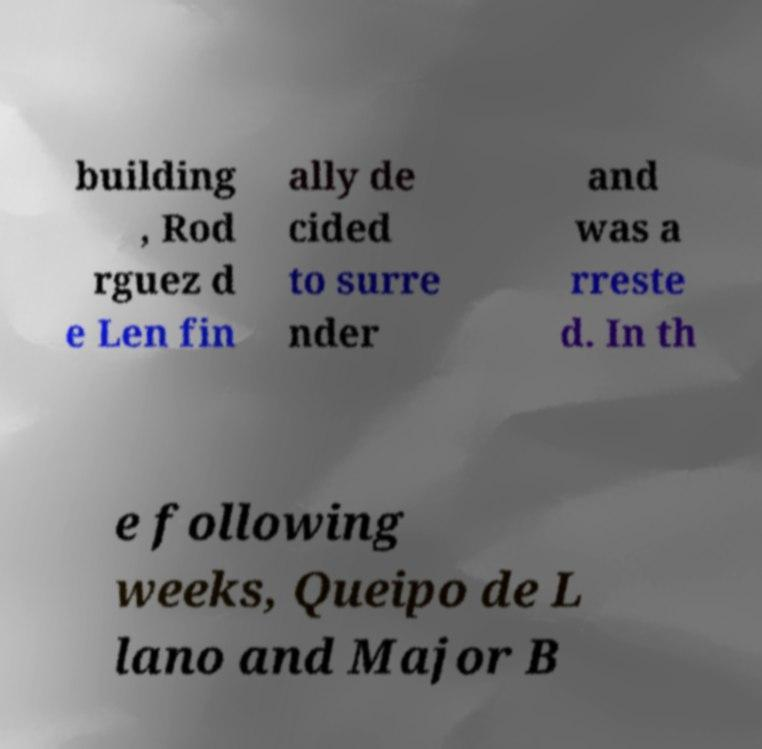Could you assist in decoding the text presented in this image and type it out clearly? building , Rod rguez d e Len fin ally de cided to surre nder and was a rreste d. In th e following weeks, Queipo de L lano and Major B 